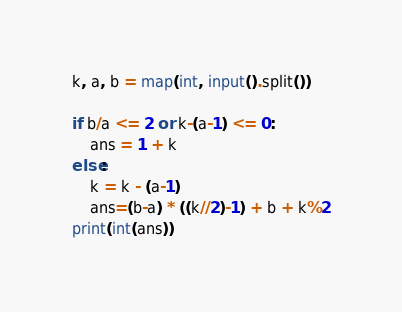<code> <loc_0><loc_0><loc_500><loc_500><_Python_>k, a, b = map(int, input().split())

if b/a <= 2 or k-(a-1) <= 0:
    ans = 1 + k
else:
    k = k - (a-1)
    ans=(b-a) * ((k//2)-1) + b + k%2
print(int(ans))</code> 